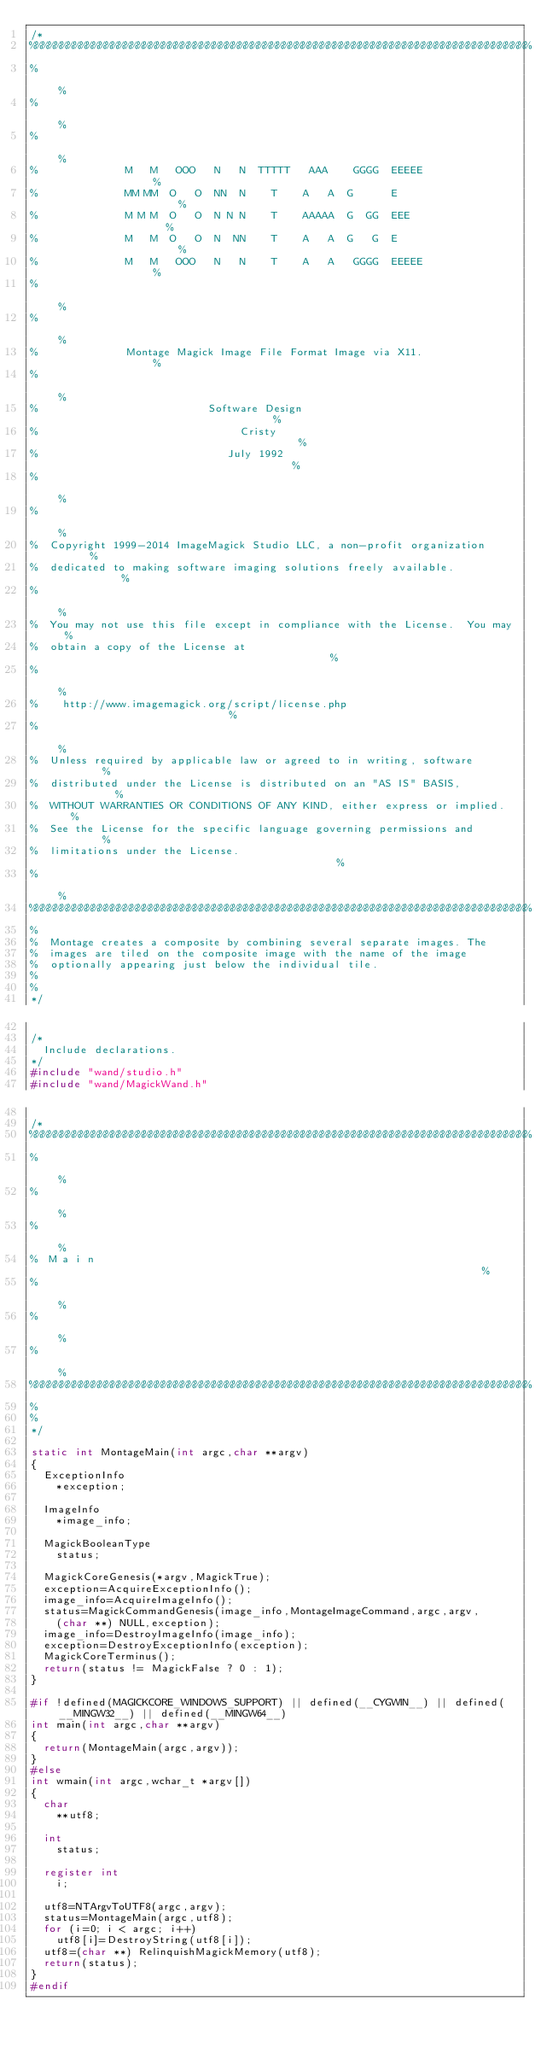<code> <loc_0><loc_0><loc_500><loc_500><_C_>/*
%%%%%%%%%%%%%%%%%%%%%%%%%%%%%%%%%%%%%%%%%%%%%%%%%%%%%%%%%%%%%%%%%%%%%%%%%%%%%%%
%                                                                             %
%                                                                             %
%                                                                             %
%              M   M   OOO   N   N  TTTTT   AAA    GGGG  EEEEE                %
%              MM MM  O   O  NN  N    T    A   A  G      E                    %
%              M M M  O   O  N N N    T    AAAAA  G  GG  EEE                  %
%              M   M  O   O  N  NN    T    A   A  G   G  E                    %
%              M   M   OOO   N   N    T    A   A   GGGG  EEEEE                %
%                                                                             %
%                                                                             %
%              Montage Magick Image File Format Image via X11.                %
%                                                                             %
%                           Software Design                                   %
%                                Cristy                                       %
%                              July 1992                                      %
%                                                                             %
%                                                                             %
%  Copyright 1999-2014 ImageMagick Studio LLC, a non-profit organization      %
%  dedicated to making software imaging solutions freely available.           %
%                                                                             %
%  You may not use this file except in compliance with the License.  You may  %
%  obtain a copy of the License at                                            %
%                                                                             %
%    http://www.imagemagick.org/script/license.php                            %
%                                                                             %
%  Unless required by applicable law or agreed to in writing, software        %
%  distributed under the License is distributed on an "AS IS" BASIS,          %
%  WITHOUT WARRANTIES OR CONDITIONS OF ANY KIND, either express or implied.   %
%  See the License for the specific language governing permissions and        %
%  limitations under the License.                                             %
%                                                                             %
%%%%%%%%%%%%%%%%%%%%%%%%%%%%%%%%%%%%%%%%%%%%%%%%%%%%%%%%%%%%%%%%%%%%%%%%%%%%%%%
%
%  Montage creates a composite by combining several separate images. The
%  images are tiled on the composite image with the name of the image
%  optionally appearing just below the individual tile.
%
%
*/

/*
  Include declarations.
*/
#include "wand/studio.h"
#include "wand/MagickWand.h"

/*
%%%%%%%%%%%%%%%%%%%%%%%%%%%%%%%%%%%%%%%%%%%%%%%%%%%%%%%%%%%%%%%%%%%%%%%%%%%%%%%
%                                                                             %
%                                                                             %
%                                                                             %
%  M a i n                                                                    %
%                                                                             %
%                                                                             %
%                                                                             %
%%%%%%%%%%%%%%%%%%%%%%%%%%%%%%%%%%%%%%%%%%%%%%%%%%%%%%%%%%%%%%%%%%%%%%%%%%%%%%%
%
%
*/

static int MontageMain(int argc,char **argv)
{
  ExceptionInfo
    *exception;

  ImageInfo
    *image_info;

  MagickBooleanType
    status;

  MagickCoreGenesis(*argv,MagickTrue);
  exception=AcquireExceptionInfo();
  image_info=AcquireImageInfo();
  status=MagickCommandGenesis(image_info,MontageImageCommand,argc,argv,
    (char **) NULL,exception);
  image_info=DestroyImageInfo(image_info);
  exception=DestroyExceptionInfo(exception);
  MagickCoreTerminus();
  return(status != MagickFalse ? 0 : 1);
}

#if !defined(MAGICKCORE_WINDOWS_SUPPORT) || defined(__CYGWIN__) || defined(__MINGW32__) || defined(__MINGW64__)
int main(int argc,char **argv)
{
  return(MontageMain(argc,argv));
}
#else
int wmain(int argc,wchar_t *argv[])
{
  char
    **utf8;

  int
    status;

  register int
    i;

  utf8=NTArgvToUTF8(argc,argv);
  status=MontageMain(argc,utf8);
  for (i=0; i < argc; i++)
    utf8[i]=DestroyString(utf8[i]);
  utf8=(char **) RelinquishMagickMemory(utf8);
  return(status);
}
#endif
</code> 